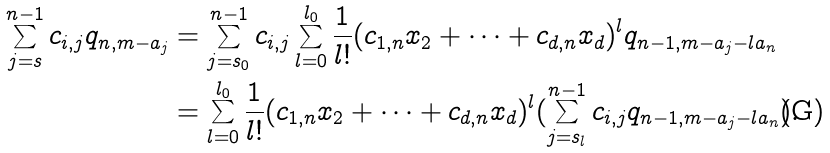<formula> <loc_0><loc_0><loc_500><loc_500>\sum _ { j = s } ^ { n - 1 } c _ { i , j } q _ { n , m - a _ { j } } & = \sum _ { j = s _ { 0 } } ^ { n - 1 } c _ { i , j } \sum _ { l = 0 } ^ { l _ { 0 } } \frac { 1 } { l ! } ( c _ { 1 , n } x _ { 2 } + \dots + c _ { d , n } x _ { d } ) ^ { l } q _ { n - 1 , m - a _ { j } - l a _ { n } } \\ & = \sum _ { l = 0 } ^ { l _ { 0 } } \frac { 1 } { l ! } ( c _ { 1 , n } x _ { 2 } + \dots + c _ { d , n } x _ { d } ) ^ { l } ( \sum _ { j = s _ { l } } ^ { n - 1 } c _ { i , j } q _ { n - 1 , m - a _ { j } - l a _ { n } } ) .</formula> 